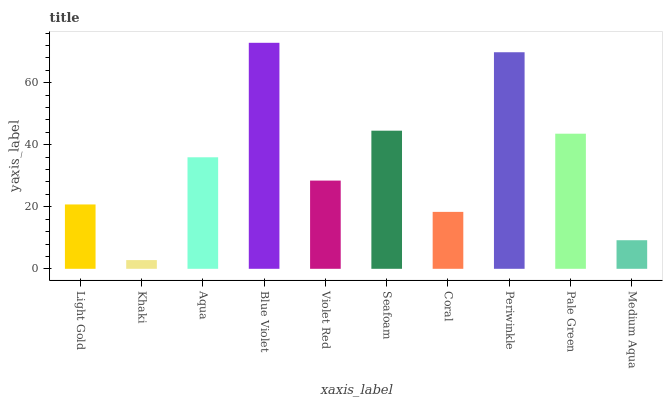Is Aqua the minimum?
Answer yes or no. No. Is Aqua the maximum?
Answer yes or no. No. Is Aqua greater than Khaki?
Answer yes or no. Yes. Is Khaki less than Aqua?
Answer yes or no. Yes. Is Khaki greater than Aqua?
Answer yes or no. No. Is Aqua less than Khaki?
Answer yes or no. No. Is Aqua the high median?
Answer yes or no. Yes. Is Violet Red the low median?
Answer yes or no. Yes. Is Periwinkle the high median?
Answer yes or no. No. Is Coral the low median?
Answer yes or no. No. 